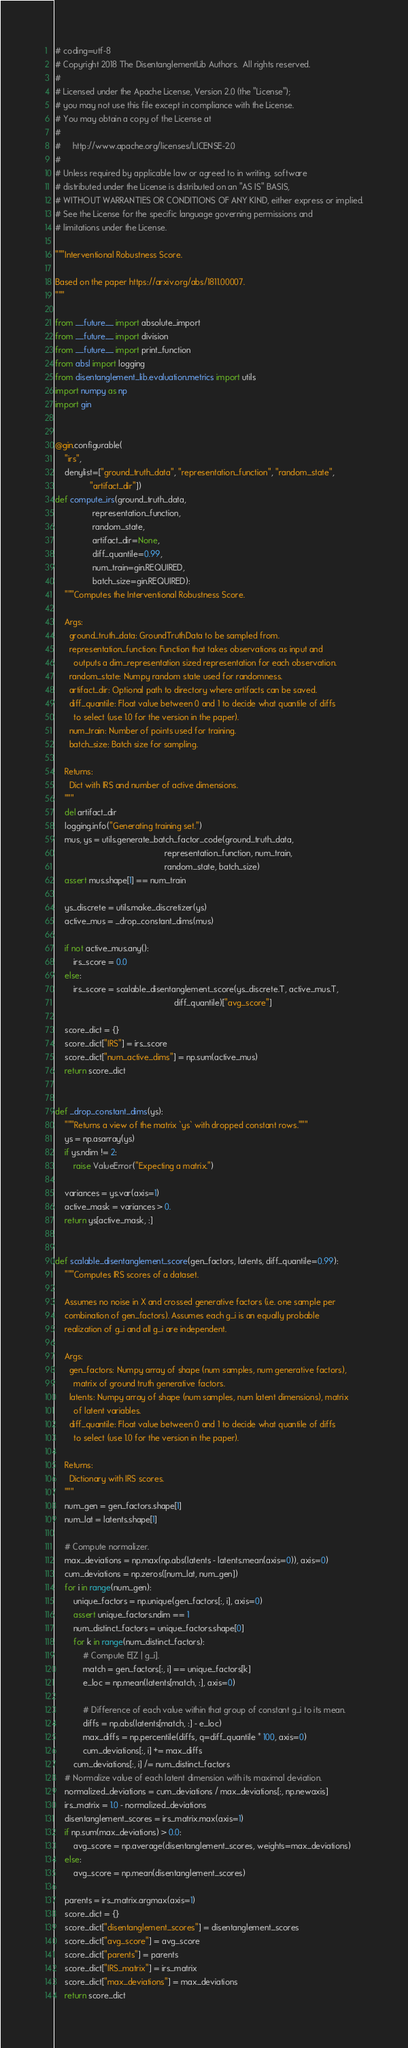<code> <loc_0><loc_0><loc_500><loc_500><_Python_># coding=utf-8
# Copyright 2018 The DisentanglementLib Authors.  All rights reserved.
#
# Licensed under the Apache License, Version 2.0 (the "License");
# you may not use this file except in compliance with the License.
# You may obtain a copy of the License at
#
#     http://www.apache.org/licenses/LICENSE-2.0
#
# Unless required by applicable law or agreed to in writing, software
# distributed under the License is distributed on an "AS IS" BASIS,
# WITHOUT WARRANTIES OR CONDITIONS OF ANY KIND, either express or implied.
# See the License for the specific language governing permissions and
# limitations under the License.

"""Interventional Robustness Score.

Based on the paper https://arxiv.org/abs/1811.00007.
"""

from __future__ import absolute_import
from __future__ import division
from __future__ import print_function
from absl import logging
from disentanglement_lib.evaluation.metrics import utils
import numpy as np
import gin


@gin.configurable(
    "irs",
    denylist=["ground_truth_data", "representation_function", "random_state",
               "artifact_dir"])
def compute_irs(ground_truth_data,
                representation_function,
                random_state,
                artifact_dir=None,
                diff_quantile=0.99,
                num_train=gin.REQUIRED,
                batch_size=gin.REQUIRED):
    """Computes the Interventional Robustness Score.

    Args:
      ground_truth_data: GroundTruthData to be sampled from.
      representation_function: Function that takes observations as input and
        outputs a dim_representation sized representation for each observation.
      random_state: Numpy random state used for randomness.
      artifact_dir: Optional path to directory where artifacts can be saved.
      diff_quantile: Float value between 0 and 1 to decide what quantile of diffs
        to select (use 1.0 for the version in the paper).
      num_train: Number of points used for training.
      batch_size: Batch size for sampling.

    Returns:
      Dict with IRS and number of active dimensions.
    """
    del artifact_dir
    logging.info("Generating training set.")
    mus, ys = utils.generate_batch_factor_code(ground_truth_data,
                                               representation_function, num_train,
                                               random_state, batch_size)
    assert mus.shape[1] == num_train

    ys_discrete = utils.make_discretizer(ys)
    active_mus = _drop_constant_dims(mus)

    if not active_mus.any():
        irs_score = 0.0
    else:
        irs_score = scalable_disentanglement_score(ys_discrete.T, active_mus.T,
                                                   diff_quantile)["avg_score"]

    score_dict = {}
    score_dict["IRS"] = irs_score
    score_dict["num_active_dims"] = np.sum(active_mus)
    return score_dict


def _drop_constant_dims(ys):
    """Returns a view of the matrix `ys` with dropped constant rows."""
    ys = np.asarray(ys)
    if ys.ndim != 2:
        raise ValueError("Expecting a matrix.")

    variances = ys.var(axis=1)
    active_mask = variances > 0.
    return ys[active_mask, :]


def scalable_disentanglement_score(gen_factors, latents, diff_quantile=0.99):
    """Computes IRS scores of a dataset.

    Assumes no noise in X and crossed generative factors (i.e. one sample per
    combination of gen_factors). Assumes each g_i is an equally probable
    realization of g_i and all g_i are independent.

    Args:
      gen_factors: Numpy array of shape (num samples, num generative factors),
        matrix of ground truth generative factors.
      latents: Numpy array of shape (num samples, num latent dimensions), matrix
        of latent variables.
      diff_quantile: Float value between 0 and 1 to decide what quantile of diffs
        to select (use 1.0 for the version in the paper).

    Returns:
      Dictionary with IRS scores.
    """
    num_gen = gen_factors.shape[1]
    num_lat = latents.shape[1]

    # Compute normalizer.
    max_deviations = np.max(np.abs(latents - latents.mean(axis=0)), axis=0)
    cum_deviations = np.zeros([num_lat, num_gen])
    for i in range(num_gen):
        unique_factors = np.unique(gen_factors[:, i], axis=0)
        assert unique_factors.ndim == 1
        num_distinct_factors = unique_factors.shape[0]
        for k in range(num_distinct_factors):
            # Compute E[Z | g_i].
            match = gen_factors[:, i] == unique_factors[k]
            e_loc = np.mean(latents[match, :], axis=0)

            # Difference of each value within that group of constant g_i to its mean.
            diffs = np.abs(latents[match, :] - e_loc)
            max_diffs = np.percentile(diffs, q=diff_quantile * 100, axis=0)
            cum_deviations[:, i] += max_diffs
        cum_deviations[:, i] /= num_distinct_factors
    # Normalize value of each latent dimension with its maximal deviation.
    normalized_deviations = cum_deviations / max_deviations[:, np.newaxis]
    irs_matrix = 1.0 - normalized_deviations
    disentanglement_scores = irs_matrix.max(axis=1)
    if np.sum(max_deviations) > 0.0:
        avg_score = np.average(disentanglement_scores, weights=max_deviations)
    else:
        avg_score = np.mean(disentanglement_scores)

    parents = irs_matrix.argmax(axis=1)
    score_dict = {}
    score_dict["disentanglement_scores"] = disentanglement_scores
    score_dict["avg_score"] = avg_score
    score_dict["parents"] = parents
    score_dict["IRS_matrix"] = irs_matrix
    score_dict["max_deviations"] = max_deviations
    return score_dict
</code> 